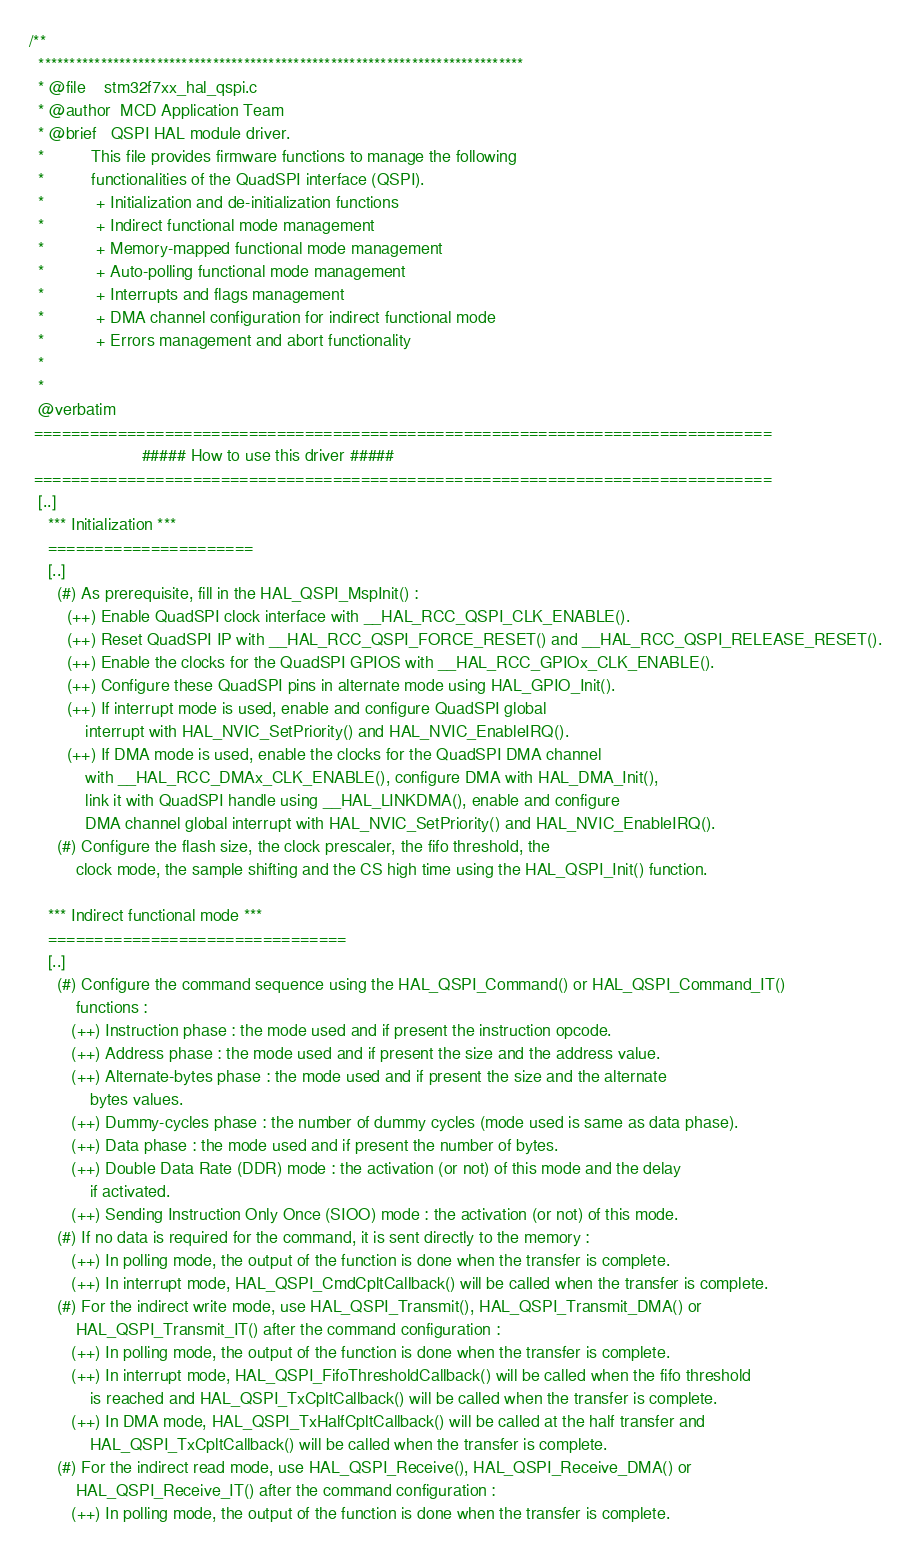<code> <loc_0><loc_0><loc_500><loc_500><_C_>/**
  ******************************************************************************
  * @file    stm32f7xx_hal_qspi.c
  * @author  MCD Application Team
  * @brief   QSPI HAL module driver.
  *          This file provides firmware functions to manage the following 
  *          functionalities of the QuadSPI interface (QSPI).
  *           + Initialization and de-initialization functions
  *           + Indirect functional mode management
  *           + Memory-mapped functional mode management
  *           + Auto-polling functional mode management
  *           + Interrupts and flags management
  *           + DMA channel configuration for indirect functional mode
  *           + Errors management and abort functionality
  *
  *
  @verbatim
 ===============================================================================
                        ##### How to use this driver #####
 ===============================================================================
  [..]
    *** Initialization ***
    ======================
    [..]
      (#) As prerequisite, fill in the HAL_QSPI_MspInit() :
        (++) Enable QuadSPI clock interface with __HAL_RCC_QSPI_CLK_ENABLE().
        (++) Reset QuadSPI IP with __HAL_RCC_QSPI_FORCE_RESET() and __HAL_RCC_QSPI_RELEASE_RESET().
        (++) Enable the clocks for the QuadSPI GPIOS with __HAL_RCC_GPIOx_CLK_ENABLE().
        (++) Configure these QuadSPI pins in alternate mode using HAL_GPIO_Init().
        (++) If interrupt mode is used, enable and configure QuadSPI global
            interrupt with HAL_NVIC_SetPriority() and HAL_NVIC_EnableIRQ().
        (++) If DMA mode is used, enable the clocks for the QuadSPI DMA channel 
            with __HAL_RCC_DMAx_CLK_ENABLE(), configure DMA with HAL_DMA_Init(), 
            link it with QuadSPI handle using __HAL_LINKDMA(), enable and configure 
            DMA channel global interrupt with HAL_NVIC_SetPriority() and HAL_NVIC_EnableIRQ().
      (#) Configure the flash size, the clock prescaler, the fifo threshold, the
          clock mode, the sample shifting and the CS high time using the HAL_QSPI_Init() function.

    *** Indirect functional mode ***
    ================================
    [..]
      (#) Configure the command sequence using the HAL_QSPI_Command() or HAL_QSPI_Command_IT() 
          functions :
         (++) Instruction phase : the mode used and if present the instruction opcode.
         (++) Address phase : the mode used and if present the size and the address value.
         (++) Alternate-bytes phase : the mode used and if present the size and the alternate 
             bytes values.
         (++) Dummy-cycles phase : the number of dummy cycles (mode used is same as data phase).
         (++) Data phase : the mode used and if present the number of bytes.
         (++) Double Data Rate (DDR) mode : the activation (or not) of this mode and the delay 
             if activated.
         (++) Sending Instruction Only Once (SIOO) mode : the activation (or not) of this mode.
      (#) If no data is required for the command, it is sent directly to the memory :
         (++) In polling mode, the output of the function is done when the transfer is complete.
         (++) In interrupt mode, HAL_QSPI_CmdCpltCallback() will be called when the transfer is complete.
      (#) For the indirect write mode, use HAL_QSPI_Transmit(), HAL_QSPI_Transmit_DMA() or 
          HAL_QSPI_Transmit_IT() after the command configuration :
         (++) In polling mode, the output of the function is done when the transfer is complete.
         (++) In interrupt mode, HAL_QSPI_FifoThresholdCallback() will be called when the fifo threshold 
             is reached and HAL_QSPI_TxCpltCallback() will be called when the transfer is complete.
         (++) In DMA mode, HAL_QSPI_TxHalfCpltCallback() will be called at the half transfer and 
             HAL_QSPI_TxCpltCallback() will be called when the transfer is complete.
      (#) For the indirect read mode, use HAL_QSPI_Receive(), HAL_QSPI_Receive_DMA() or 
          HAL_QSPI_Receive_IT() after the command configuration :
         (++) In polling mode, the output of the function is done when the transfer is complete.</code> 